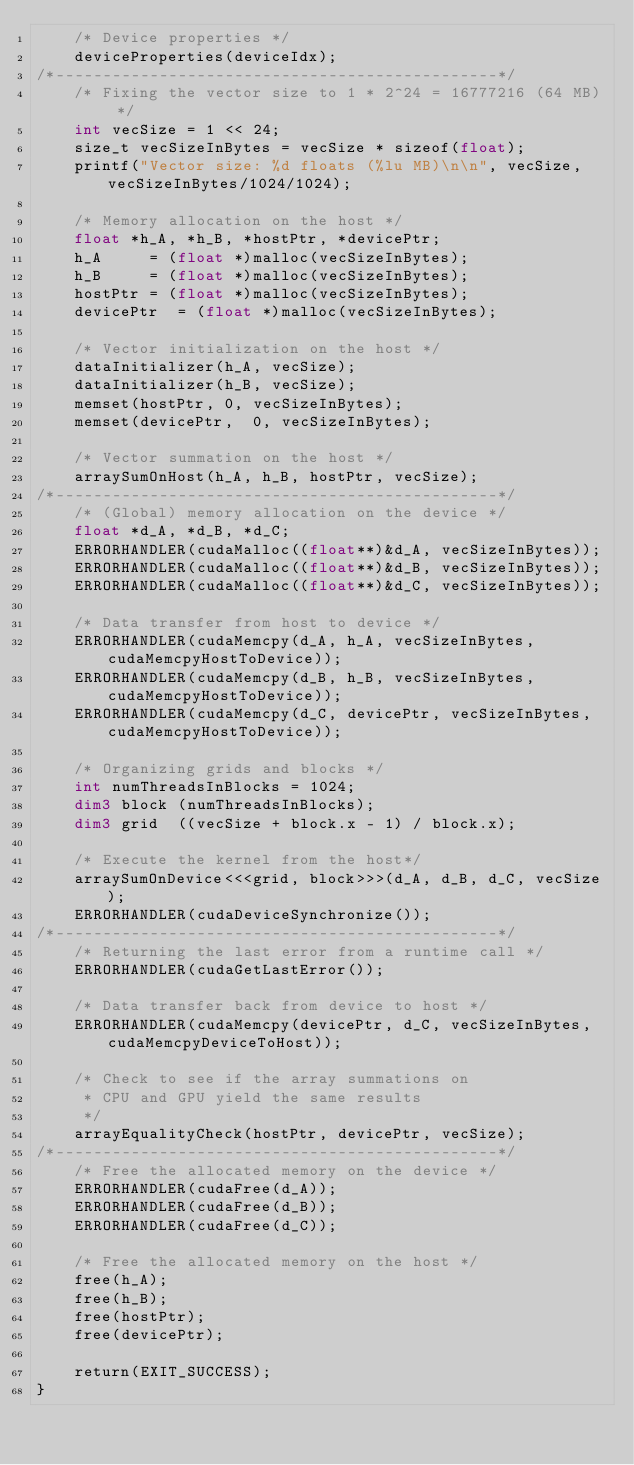<code> <loc_0><loc_0><loc_500><loc_500><_Cuda_>    /* Device properties */
    deviceProperties(deviceIdx);
/*-----------------------------------------------*/
    /* Fixing the vector size to 1 * 2^24 = 16777216 (64 MB) */
    int vecSize = 1 << 24;
    size_t vecSizeInBytes = vecSize * sizeof(float);
    printf("Vector size: %d floats (%lu MB)\n\n", vecSize, vecSizeInBytes/1024/1024);

    /* Memory allocation on the host */
    float *h_A, *h_B, *hostPtr, *devicePtr;
    h_A     = (float *)malloc(vecSizeInBytes);
    h_B     = (float *)malloc(vecSizeInBytes);
    hostPtr = (float *)malloc(vecSizeInBytes);
    devicePtr  = (float *)malloc(vecSizeInBytes);

    /* Vector initialization on the host */
    dataInitializer(h_A, vecSize);
    dataInitializer(h_B, vecSize);
    memset(hostPtr, 0, vecSizeInBytes);
    memset(devicePtr,  0, vecSizeInBytes);

    /* Vector summation on the host */
    arraySumOnHost(h_A, h_B, hostPtr, vecSize);
/*-----------------------------------------------*/
    /* (Global) memory allocation on the device */
    float *d_A, *d_B, *d_C;
    ERRORHANDLER(cudaMalloc((float**)&d_A, vecSizeInBytes));
    ERRORHANDLER(cudaMalloc((float**)&d_B, vecSizeInBytes));
    ERRORHANDLER(cudaMalloc((float**)&d_C, vecSizeInBytes));

    /* Data transfer from host to device */
    ERRORHANDLER(cudaMemcpy(d_A, h_A, vecSizeInBytes, cudaMemcpyHostToDevice));
    ERRORHANDLER(cudaMemcpy(d_B, h_B, vecSizeInBytes, cudaMemcpyHostToDevice));
    ERRORHANDLER(cudaMemcpy(d_C, devicePtr, vecSizeInBytes, cudaMemcpyHostToDevice));

    /* Organizing grids and blocks */
    int numThreadsInBlocks = 1024;
    dim3 block (numThreadsInBlocks);
    dim3 grid  ((vecSize + block.x - 1) / block.x);

    /* Execute the kernel from the host*/
    arraySumOnDevice<<<grid, block>>>(d_A, d_B, d_C, vecSize);
    ERRORHANDLER(cudaDeviceSynchronize());
/*-----------------------------------------------*/
    /* Returning the last error from a runtime call */
    ERRORHANDLER(cudaGetLastError());

    /* Data transfer back from device to host */
    ERRORHANDLER(cudaMemcpy(devicePtr, d_C, vecSizeInBytes, cudaMemcpyDeviceToHost));

    /* Check to see if the array summations on 
     * CPU and GPU yield the same results 
     */
    arrayEqualityCheck(hostPtr, devicePtr, vecSize);
/*-----------------------------------------------*/
    /* Free the allocated memory on the device */
    ERRORHANDLER(cudaFree(d_A));
    ERRORHANDLER(cudaFree(d_B));
    ERRORHANDLER(cudaFree(d_C));

    /* Free the allocated memory on the host */
    free(h_A);
    free(h_B);
    free(hostPtr);
    free(devicePtr);

    return(EXIT_SUCCESS);
}
</code> 